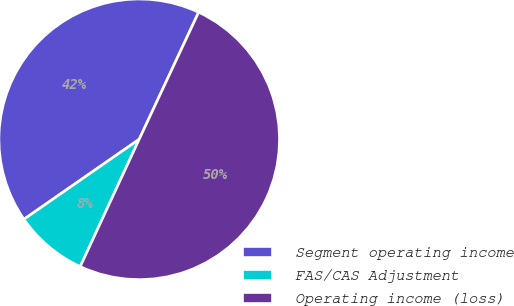Convert chart. <chart><loc_0><loc_0><loc_500><loc_500><pie_chart><fcel>Segment operating income<fcel>FAS/CAS Adjustment<fcel>Operating income (loss)<nl><fcel>41.62%<fcel>8.44%<fcel>49.94%<nl></chart> 